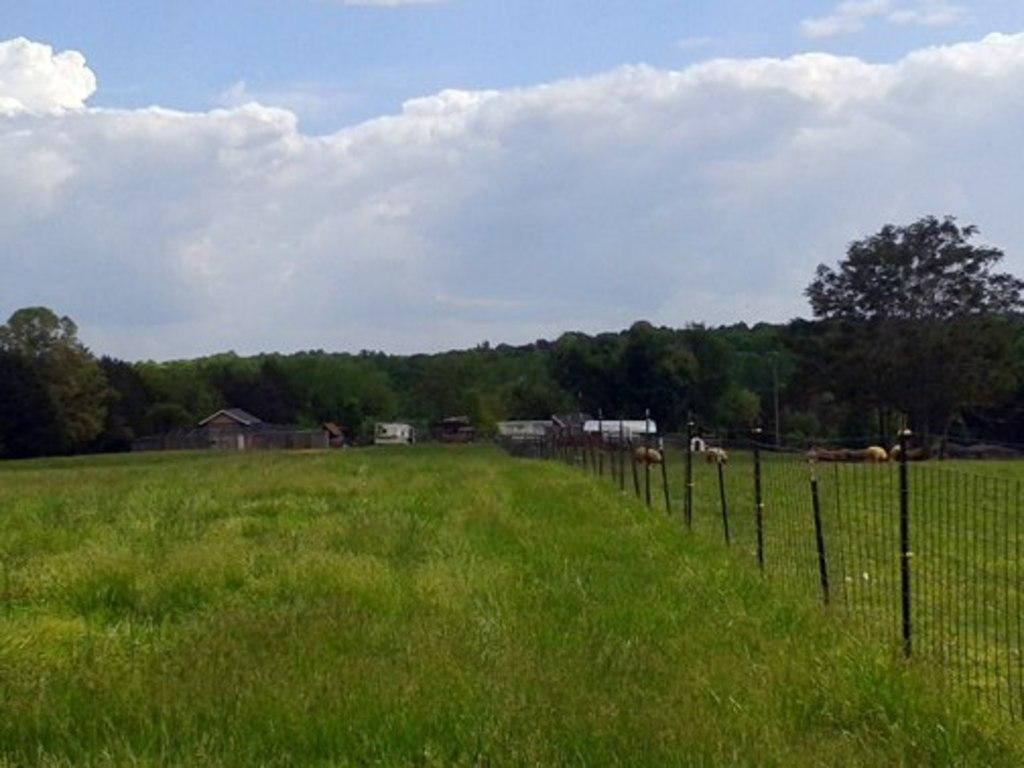What type of natural elements can be seen in the image? There are trees and plants in the image. What type of man-made structures are present in the image? There are houses in the image. What type of barrier can be seen in the image? There is fencing in the image. What type of living organisms can be seen in the image? There are animals in the image. What is visible in the background of the image? The sky is visible in the background of the image, and there are clouds present. What type of street can be seen in the image? There is no street present in the image. What type of furniture can be seen in the bedroom in the image? There is no bedroom present in the image. 